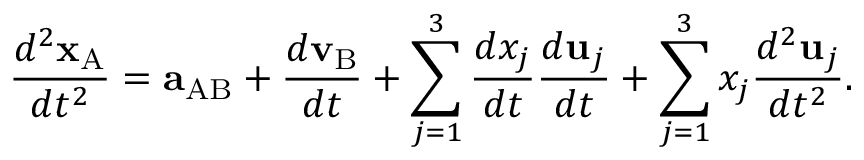Convert formula to latex. <formula><loc_0><loc_0><loc_500><loc_500>{ \frac { d ^ { 2 } x _ { A } } { d t ^ { 2 } } } = a _ { A B } + { \frac { d v _ { B } } { d t } } + \sum _ { j = 1 } ^ { 3 } { \frac { d x _ { j } } { d t } } { \frac { d u _ { j } } { d t } } + \sum _ { j = 1 } ^ { 3 } x _ { j } { \frac { d ^ { 2 } u _ { j } } { d t ^ { 2 } } } .</formula> 